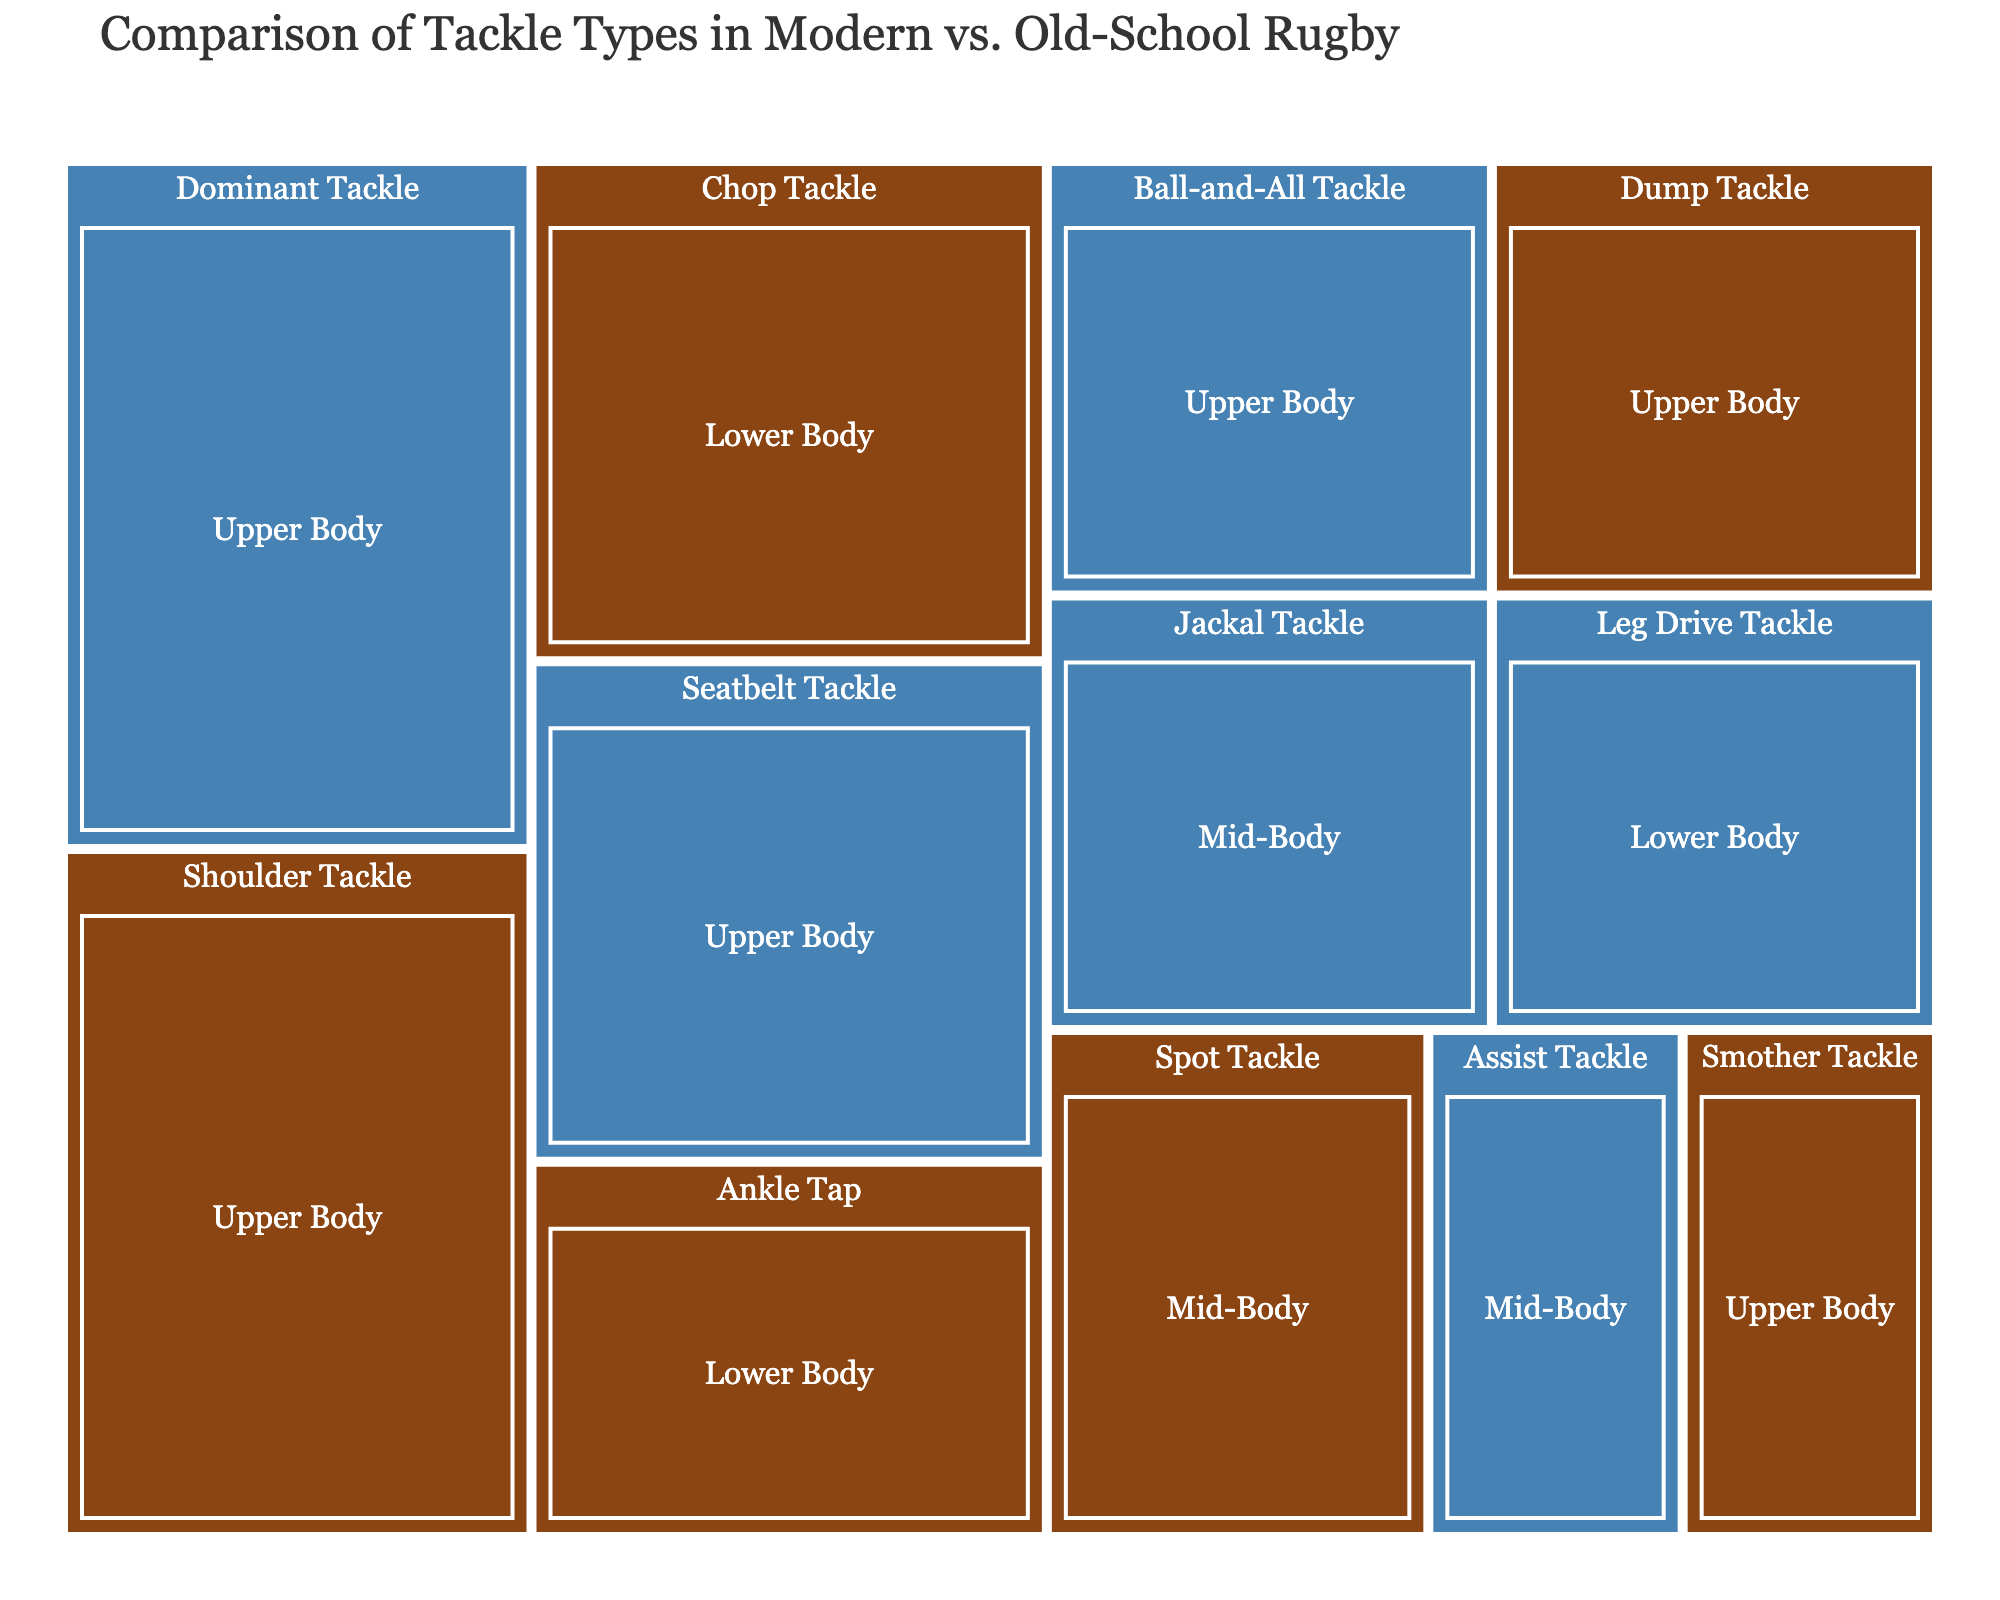What's the title of the treemap? The title is displayed at the top of the figure, indicating the overall purpose and context of the visualization.
Answer: Comparison of Tackle Types in Modern vs. Old-School Rugby Which tackle type has the highest percentage in the Old-School category? Look at the area of the rectangles within the Old-School category; the one with the largest area represents the highest percentage.
Answer: Shoulder Tackle What are the different body areas represented in the figure? The body areas are indicated by the subcategories within both the Old-School and Modern categories. Look at the labels within each category.
Answer: Upper Body, Lower Body, Mid-Body Which tackle type has a higher percentage in the Modern category, Dominant Tackle or Seatbelt Tackle? Compare the sizes of the rectangles for Dominant Tackle and Seatbelt Tackle within the Modern category; the bigger rectangle represents the higher percentage.
Answer: Dominant Tackle How does the percentage of Lower Body tackles compare between the Old-School and Modern categories? Sum the percentages of tackle types categorized under Lower Body for both Old-School and Modern categories, then compare the totals.
Answer: Both have a total of 15% What is the combined percentage of all Upper Body tackles in the Modern category? Sum the percentages of all tackle types listed under Upper Body within the Modern category.
Answer: 60% Which category has more diversity in tackle types? Compare the number of different tackle types listed under each category. The category with more types displayed has more diversity.
Answer: Modern What is the difference in percentage between the Ankle Tap (Old-School) and the Ball-and-All Tackle (Modern)? Subtract the percentage of Ball-and-All Tackle from the percentage of Ankle Tap.
Answer: 0% Which tackle types are exclusive to the Modern category? Identify the tackle types listed under the Modern category that are not present under the Old-School category.
Answer: Jackal Tackle, Seatbelt Tackle, Dominant Tackle, Leg Drive Tackle, Assist Tackle, Ball-and-All Tackle 